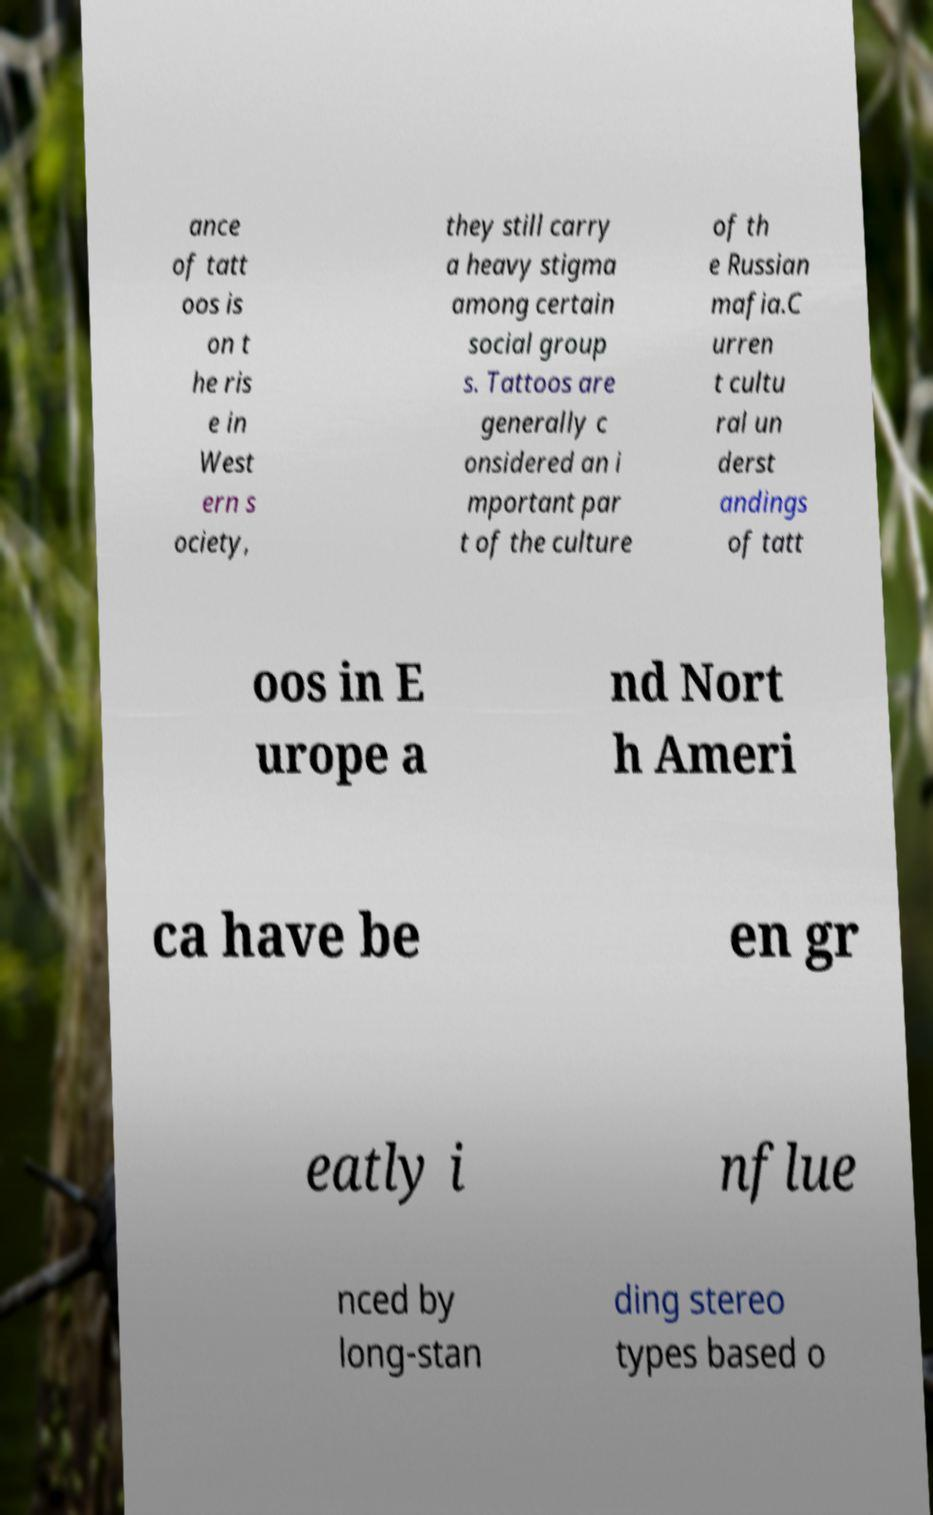Can you accurately transcribe the text from the provided image for me? ance of tatt oos is on t he ris e in West ern s ociety, they still carry a heavy stigma among certain social group s. Tattoos are generally c onsidered an i mportant par t of the culture of th e Russian mafia.C urren t cultu ral un derst andings of tatt oos in E urope a nd Nort h Ameri ca have be en gr eatly i nflue nced by long-stan ding stereo types based o 